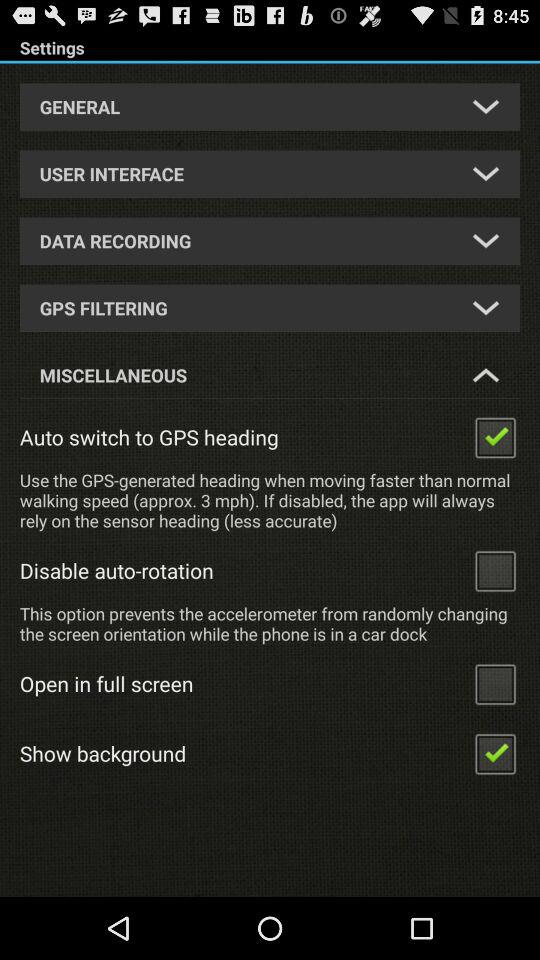What is the status of "Open in full screen"? The status of "Open in full screen" is "off". 